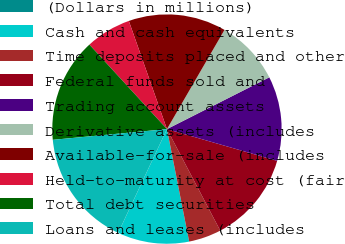Convert chart. <chart><loc_0><loc_0><loc_500><loc_500><pie_chart><fcel>(Dollars in millions)<fcel>Cash and cash equivalents<fcel>Time deposits placed and other<fcel>Federal funds sold and<fcel>Trading account assets<fcel>Derivative assets (includes<fcel>Available-for-sale (includes<fcel>Held-to-maturity at cost (fair<fcel>Total debt securities<fcel>Loans and leases (includes<nl><fcel>0.01%<fcel>10.09%<fcel>4.59%<fcel>12.84%<fcel>11.92%<fcel>9.18%<fcel>13.76%<fcel>6.43%<fcel>14.67%<fcel>16.51%<nl></chart> 